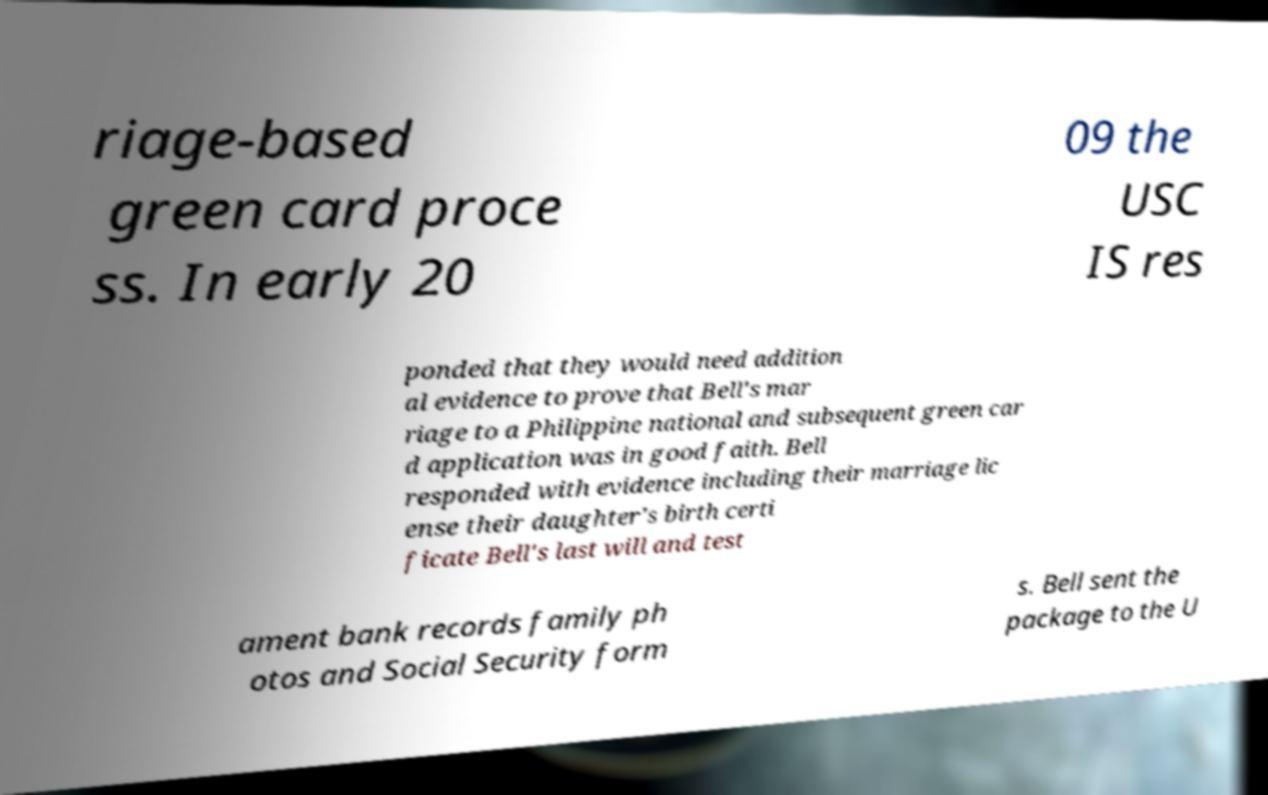What messages or text are displayed in this image? I need them in a readable, typed format. riage-based green card proce ss. In early 20 09 the USC IS res ponded that they would need addition al evidence to prove that Bell's mar riage to a Philippine national and subsequent green car d application was in good faith. Bell responded with evidence including their marriage lic ense their daughter's birth certi ficate Bell's last will and test ament bank records family ph otos and Social Security form s. Bell sent the package to the U 